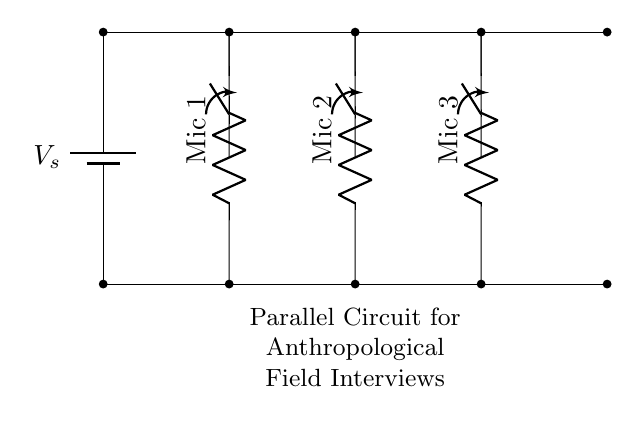What is the total number of microphones in this circuit? The circuit diagram shows three microphones represented as resistors, each connected in parallel. Thus, by counting the individual components, we find that the total is three.
Answer: three What type of circuit is represented in the diagram? The diagram specifically represents a parallel circuit where components are connected alongside each other rather than in a series. Each microphone gets the same voltage and operates independently.
Answer: parallel What is the function of the switches in this circuit? The switches allow for control over the operation of each microphone independently. If a switch is open, the corresponding microphone is turned off. Therefore, they can either allow or stop the current flow to each microphone based on the switch position.
Answer: control What is the voltage across each microphone? Because this is a parallel circuit, the voltage across each microphone is equal to the supply voltage. If the voltage of the battery is not specified in the question, we refer to it as V sub s.
Answer: V sub s If one microphone fails, will the others still function? Yes, in a parallel circuit arrangement, if one microphone (or resistor) fails, the others will still remain functional. This is due to the independent connection of each component to the power source.
Answer: yes What would happen to the current if more microphones are added? Adding more microphones in parallel will decrease the overall resistance of the circuit, which increases the total current drawn from the power source according to Ohm's law.
Answer: increase How are the microphones connected to the power source? The microphones are connected in parallel to the power source defined by the battery. Each microphone has its own path that connects it directly to the voltage supply, allowing individual operation.
Answer: in parallel 